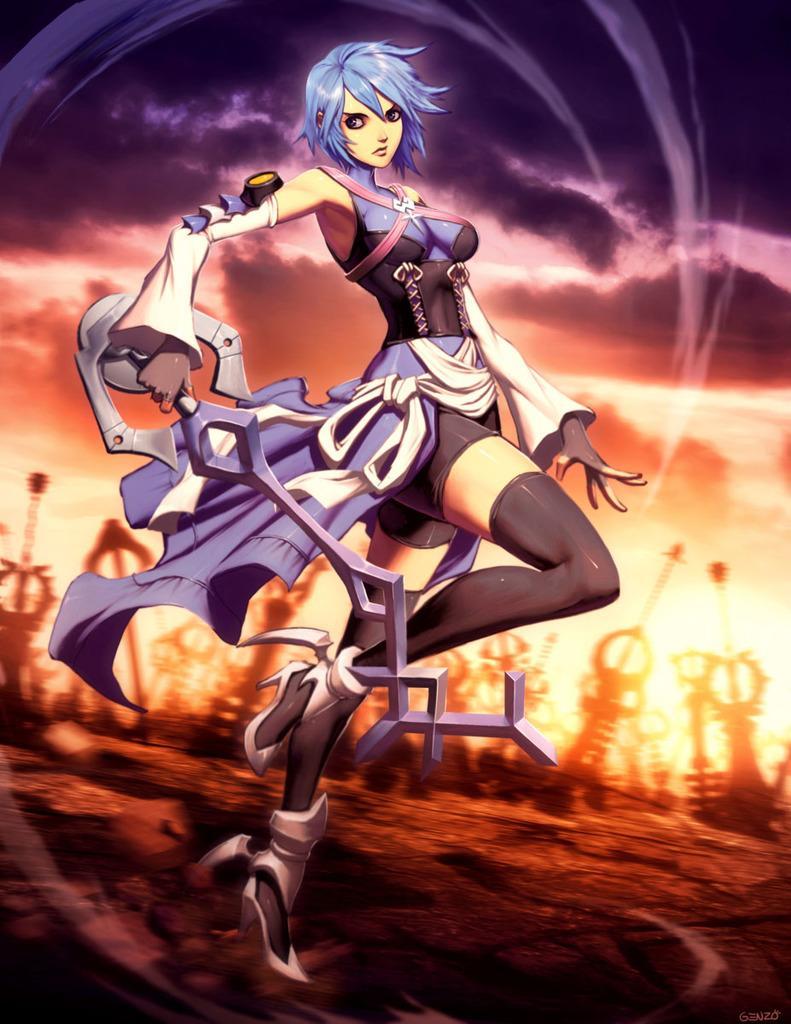Could you give a brief overview of what you see in this image? This is an animated picture. In the foreground of the picture there is a person holding weapon. In the background there are weapons and persons. 